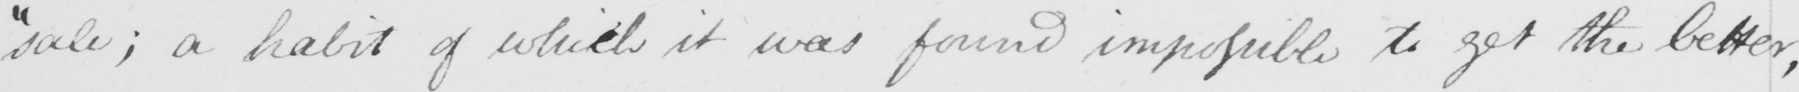Transcribe the text shown in this historical manuscript line. " sale ; a habit of which it was found impossible to get the better , 